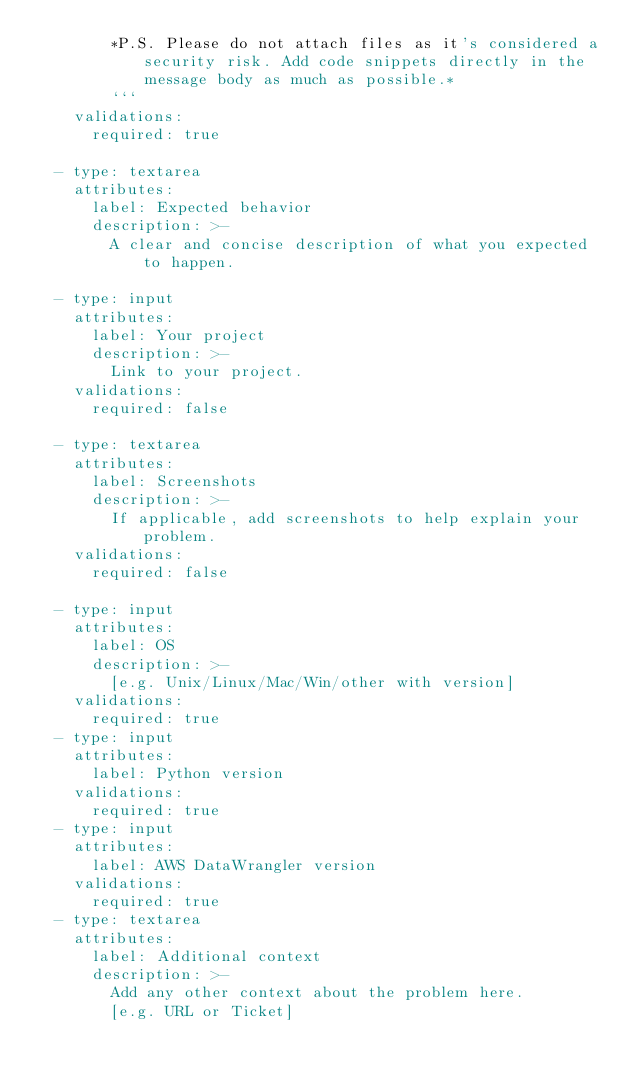<code> <loc_0><loc_0><loc_500><loc_500><_YAML_>        *P.S. Please do not attach files as it's considered a security risk. Add code snippets directly in the message body as much as possible.*
        ```
    validations:
      required: true

  - type: textarea
    attributes:
      label: Expected behavior
      description: >-
        A clear and concise description of what you expected to happen.

  - type: input
    attributes:
      label: Your project
      description: >-
        Link to your project.
    validations:
      required: false

  - type: textarea
    attributes:
      label: Screenshots
      description: >-
        If applicable, add screenshots to help explain your problem.
    validations:
      required: false

  - type: input
    attributes:
      label: OS
      description: >-
        [e.g. Unix/Linux/Mac/Win/other with version]
    validations:
      required: true
  - type: input
    attributes:
      label: Python version
    validations:
      required: true
  - type: input
    attributes:
      label: AWS DataWrangler version
    validations:
      required: true
  - type: textarea
    attributes:
      label: Additional context
      description: >-
        Add any other context about the problem here.
        [e.g. URL or Ticket]</code> 